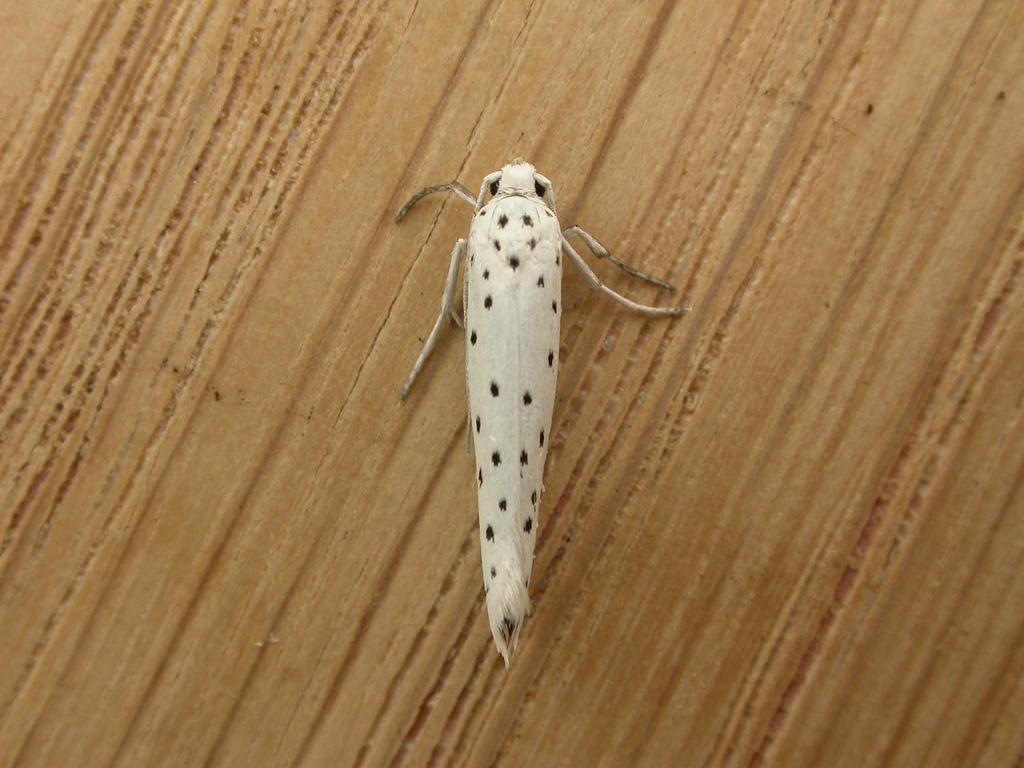What type of creature can be seen in the image? There is an insect present in the image. Where is the insect located? The insect is on a table. How many trees are visible in the image? There are no trees visible in the image; it only features an insect on a table. What is the limit of the insect's movement in the image? The image does not provide information about the insect's movement or any limits to it. Can you see a pail in the image? There is no pail present in the image. 